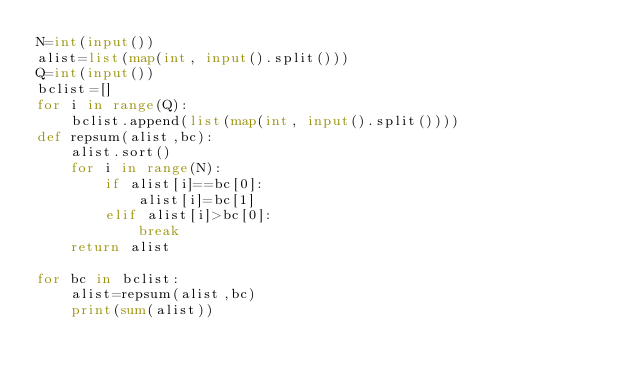<code> <loc_0><loc_0><loc_500><loc_500><_Python_>N=int(input())
alist=list(map(int, input().split()))
Q=int(input())
bclist=[]
for i in range(Q):
    bclist.append(list(map(int, input().split())))
def repsum(alist,bc):
    alist.sort()
    for i in range(N):
        if alist[i]==bc[0]:
            alist[i]=bc[1]
        elif alist[i]>bc[0]:
            break
    return alist

for bc in bclist:
    alist=repsum(alist,bc)
    print(sum(alist))
</code> 